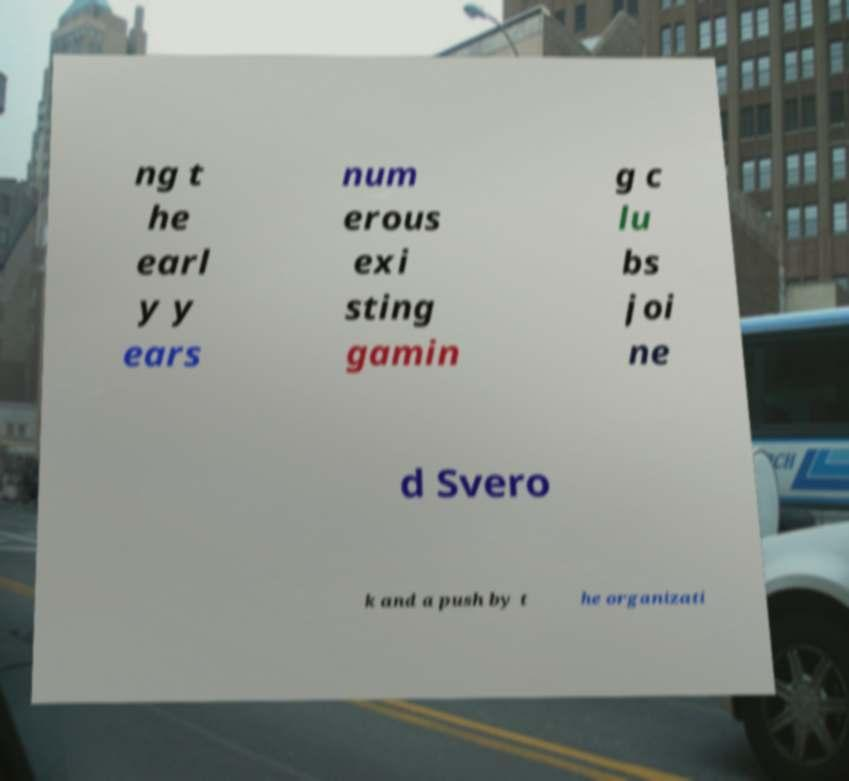There's text embedded in this image that I need extracted. Can you transcribe it verbatim? ng t he earl y y ears num erous exi sting gamin g c lu bs joi ne d Svero k and a push by t he organizati 